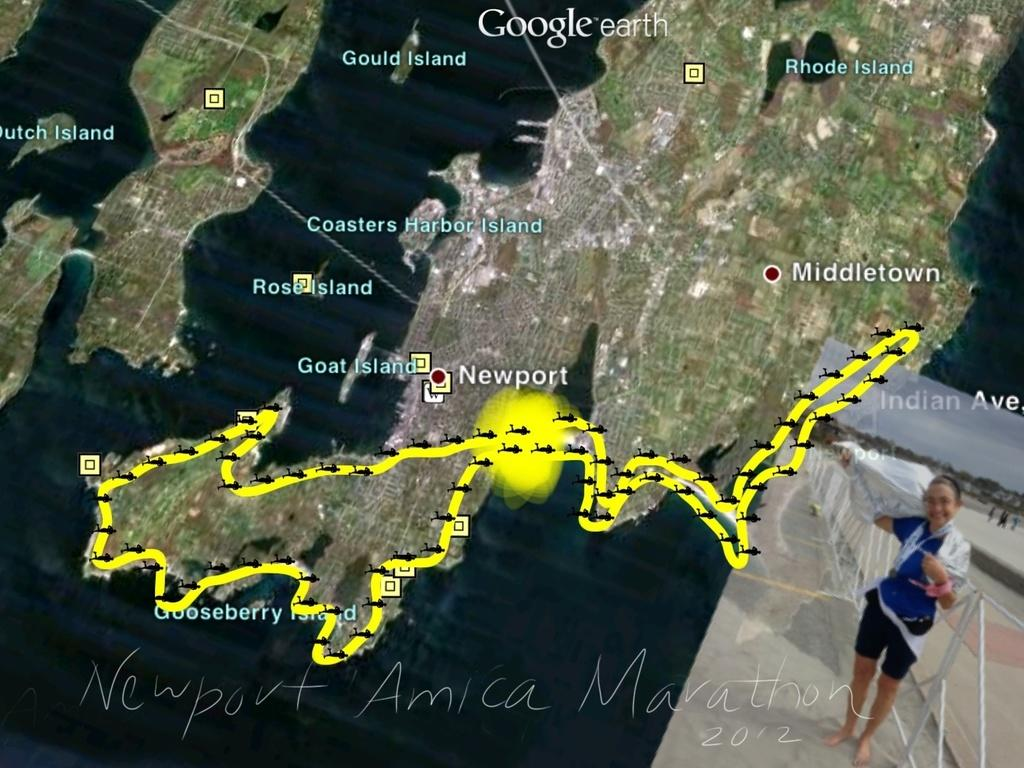What type of image is being displayed? The image is a satellite view map. Are there any people visible in the image? Yes, there is a woman in the bottom right corner of the image. What type of structure can be seen in the image? Fencing is visible in the image. What can be seen in the sky in the image? The sky is visible in the image, and clouds are present. What type of wave can be seen crashing on the shore in the image? There is no shore or wave visible in the image, as it is a satellite view map. 